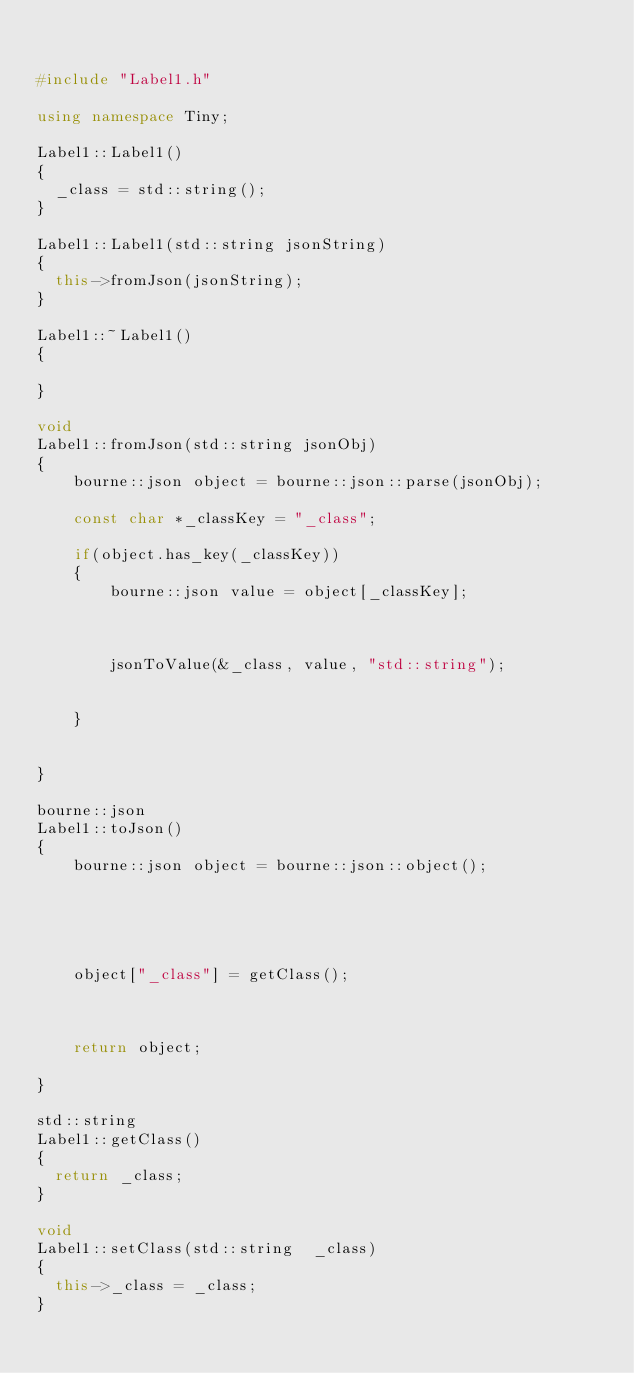<code> <loc_0><loc_0><loc_500><loc_500><_C++_>

#include "Label1.h"

using namespace Tiny;

Label1::Label1()
{
	_class = std::string();
}

Label1::Label1(std::string jsonString)
{
	this->fromJson(jsonString);
}

Label1::~Label1()
{

}

void
Label1::fromJson(std::string jsonObj)
{
    bourne::json object = bourne::json::parse(jsonObj);

    const char *_classKey = "_class";

    if(object.has_key(_classKey))
    {
        bourne::json value = object[_classKey];



        jsonToValue(&_class, value, "std::string");


    }


}

bourne::json
Label1::toJson()
{
    bourne::json object = bourne::json::object();





    object["_class"] = getClass();



    return object;

}

std::string
Label1::getClass()
{
	return _class;
}

void
Label1::setClass(std::string  _class)
{
	this->_class = _class;
}



</code> 